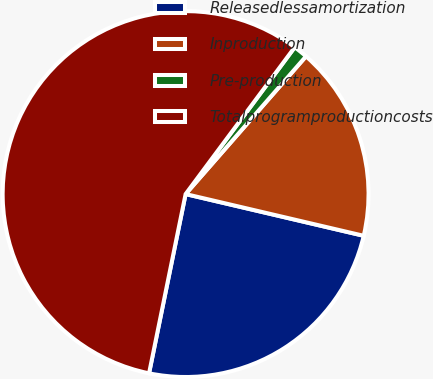Convert chart. <chart><loc_0><loc_0><loc_500><loc_500><pie_chart><fcel>Releasedlessamortization<fcel>Inproduction<fcel>Pre-production<fcel>Totalprogramproductioncosts<nl><fcel>24.54%<fcel>17.23%<fcel>1.26%<fcel>56.97%<nl></chart> 